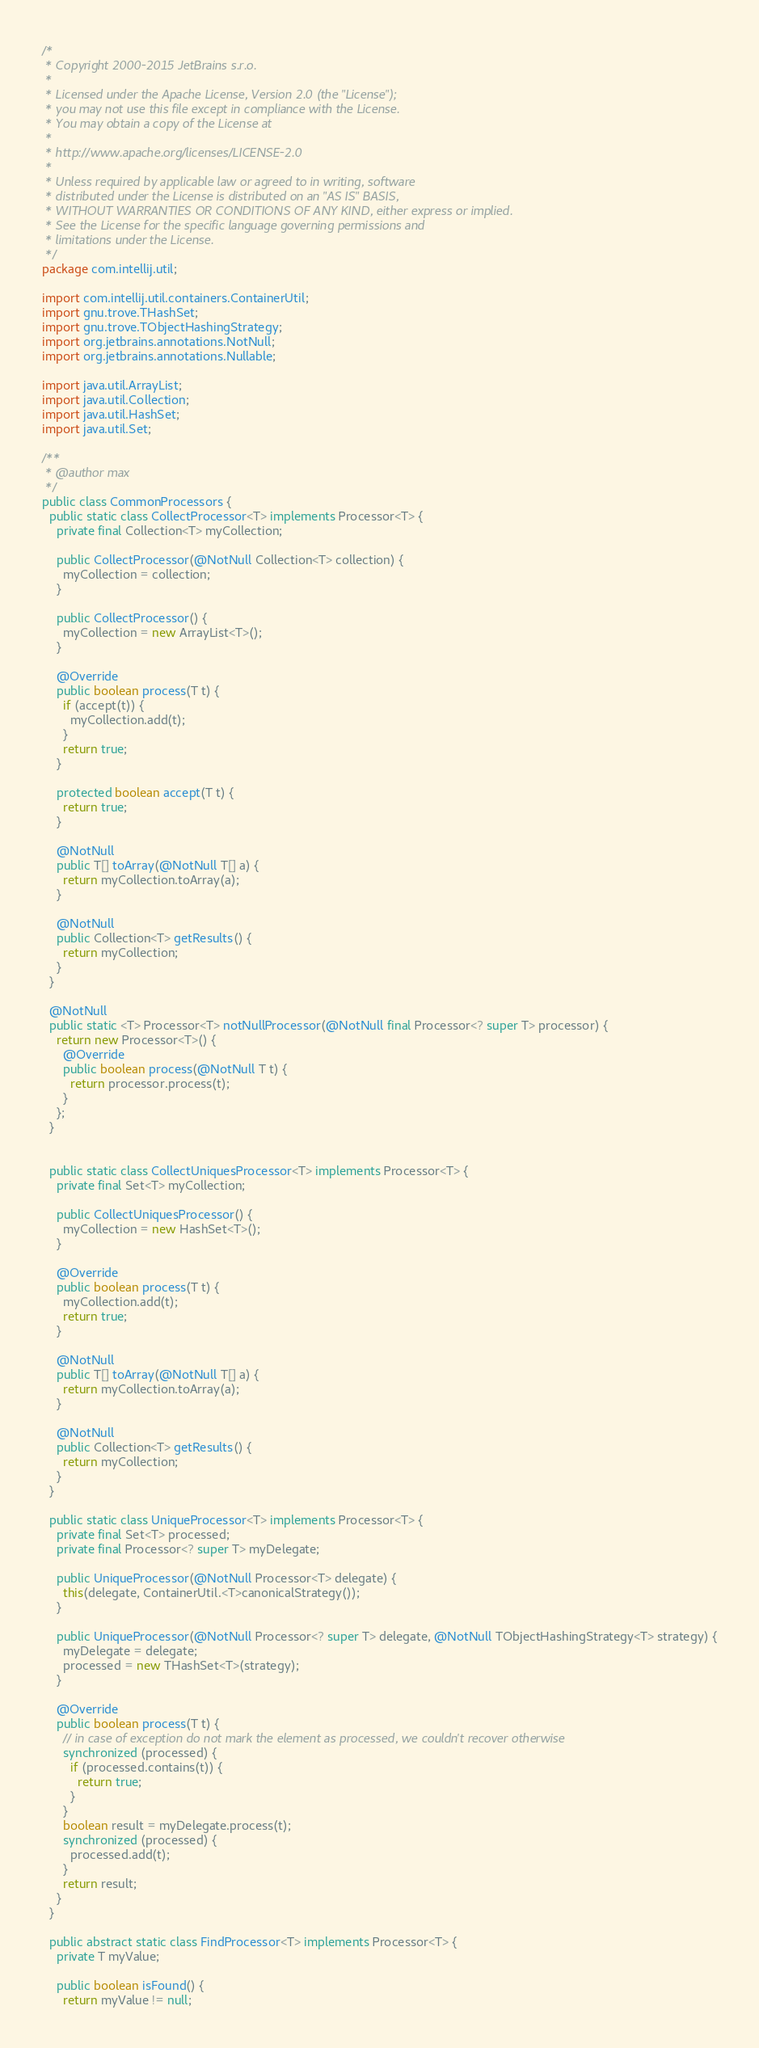<code> <loc_0><loc_0><loc_500><loc_500><_Java_>/*
 * Copyright 2000-2015 JetBrains s.r.o.
 *
 * Licensed under the Apache License, Version 2.0 (the "License");
 * you may not use this file except in compliance with the License.
 * You may obtain a copy of the License at
 *
 * http://www.apache.org/licenses/LICENSE-2.0
 *
 * Unless required by applicable law or agreed to in writing, software
 * distributed under the License is distributed on an "AS IS" BASIS,
 * WITHOUT WARRANTIES OR CONDITIONS OF ANY KIND, either express or implied.
 * See the License for the specific language governing permissions and
 * limitations under the License.
 */
package com.intellij.util;

import com.intellij.util.containers.ContainerUtil;
import gnu.trove.THashSet;
import gnu.trove.TObjectHashingStrategy;
import org.jetbrains.annotations.NotNull;
import org.jetbrains.annotations.Nullable;

import java.util.ArrayList;
import java.util.Collection;
import java.util.HashSet;
import java.util.Set;

/**
 * @author max
 */
public class CommonProcessors {
  public static class CollectProcessor<T> implements Processor<T> {
    private final Collection<T> myCollection;

    public CollectProcessor(@NotNull Collection<T> collection) {
      myCollection = collection;
    }

    public CollectProcessor() {
      myCollection = new ArrayList<T>();
    }

    @Override
    public boolean process(T t) {
      if (accept(t)) {
        myCollection.add(t);
      }
      return true;
    }

    protected boolean accept(T t) {
      return true;
    }

    @NotNull
    public T[] toArray(@NotNull T[] a) {
      return myCollection.toArray(a);
    }

    @NotNull
    public Collection<T> getResults() {
      return myCollection;
    }
  }

  @NotNull
  public static <T> Processor<T> notNullProcessor(@NotNull final Processor<? super T> processor) {
    return new Processor<T>() {
      @Override
      public boolean process(@NotNull T t) {
        return processor.process(t);
      }
    };
  }


  public static class CollectUniquesProcessor<T> implements Processor<T> {
    private final Set<T> myCollection;

    public CollectUniquesProcessor() {
      myCollection = new HashSet<T>();
    }

    @Override
    public boolean process(T t) {
      myCollection.add(t);
      return true;
    }

    @NotNull
    public T[] toArray(@NotNull T[] a) {
      return myCollection.toArray(a);
    }

    @NotNull
    public Collection<T> getResults() {
      return myCollection;
    }
  }

  public static class UniqueProcessor<T> implements Processor<T> {
    private final Set<T> processed;
    private final Processor<? super T> myDelegate;

    public UniqueProcessor(@NotNull Processor<T> delegate) {
      this(delegate, ContainerUtil.<T>canonicalStrategy());
    }

    public UniqueProcessor(@NotNull Processor<? super T> delegate, @NotNull TObjectHashingStrategy<T> strategy) {
      myDelegate = delegate;
      processed = new THashSet<T>(strategy);
    }

    @Override
    public boolean process(T t) {
      // in case of exception do not mark the element as processed, we couldn't recover otherwise
      synchronized (processed) {
        if (processed.contains(t)) {
          return true;
        }
      }
      boolean result = myDelegate.process(t);
      synchronized (processed) {
        processed.add(t);
      }
      return result;
    }
  }

  public abstract static class FindProcessor<T> implements Processor<T> {
    private T myValue;

    public boolean isFound() {
      return myValue != null;</code> 